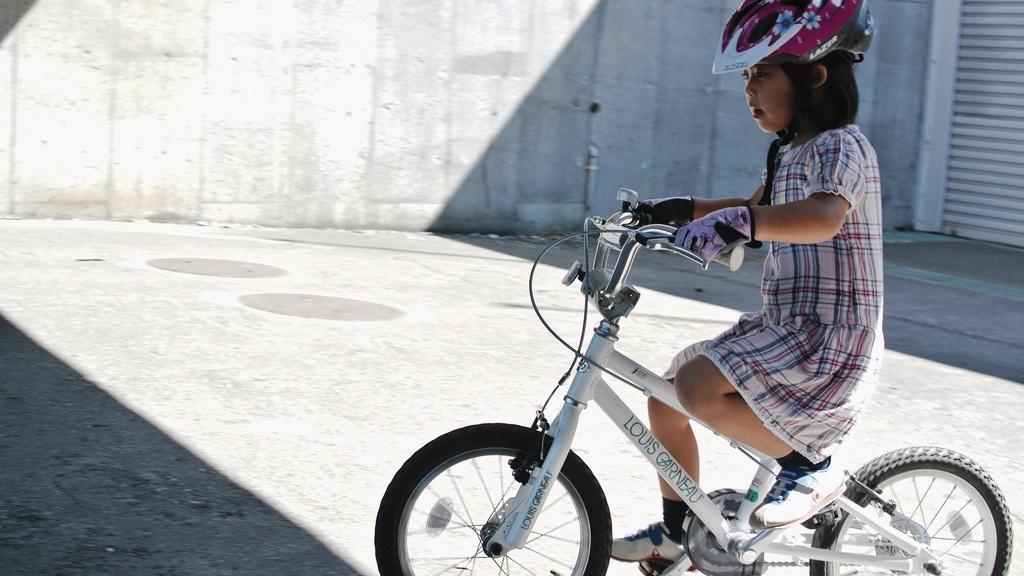Please provide a concise description of this image. In the foreground of the picture there is a girl riding a bicycle, she is wearing a helmet. To the top right there is a shutter. In the background there is a wall. 